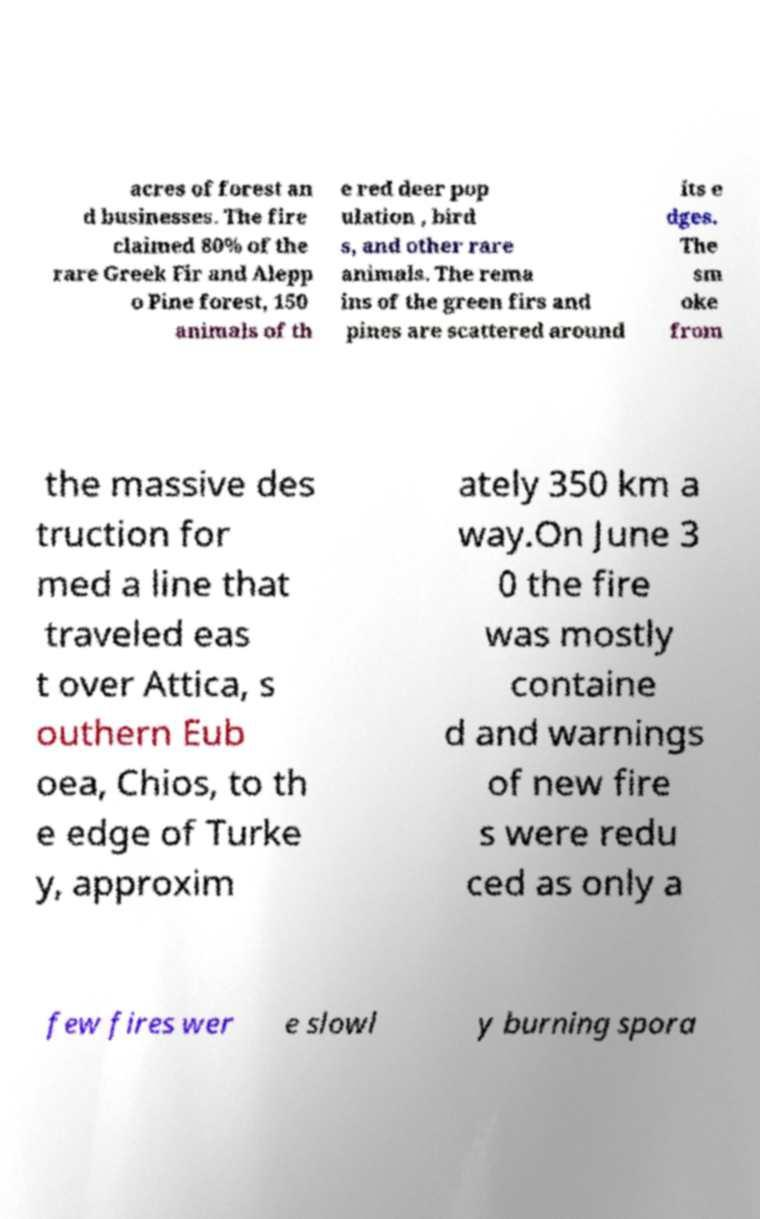There's text embedded in this image that I need extracted. Can you transcribe it verbatim? acres of forest an d businesses. The fire claimed 80% of the rare Greek Fir and Alepp o Pine forest, 150 animals of th e red deer pop ulation , bird s, and other rare animals. The rema ins of the green firs and pines are scattered around its e dges. The sm oke from the massive des truction for med a line that traveled eas t over Attica, s outhern Eub oea, Chios, to th e edge of Turke y, approxim ately 350 km a way.On June 3 0 the fire was mostly containe d and warnings of new fire s were redu ced as only a few fires wer e slowl y burning spora 